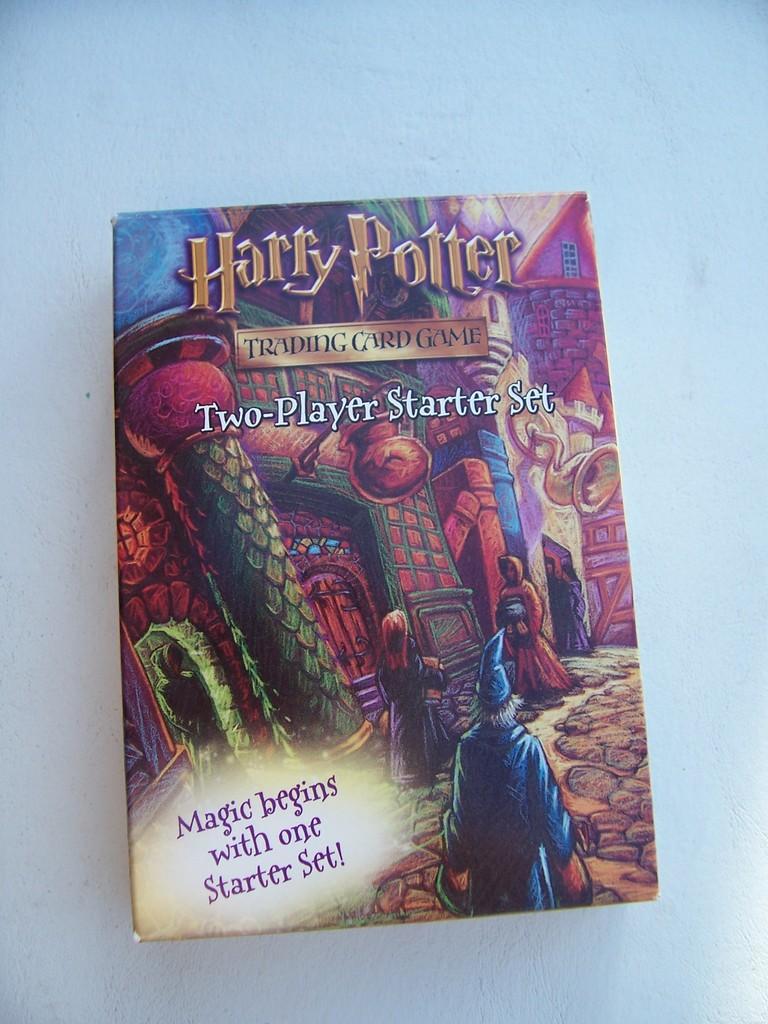What kind of game is this?
Offer a very short reply. Trading card game. How many players is this game for?
Give a very brief answer. Two. 